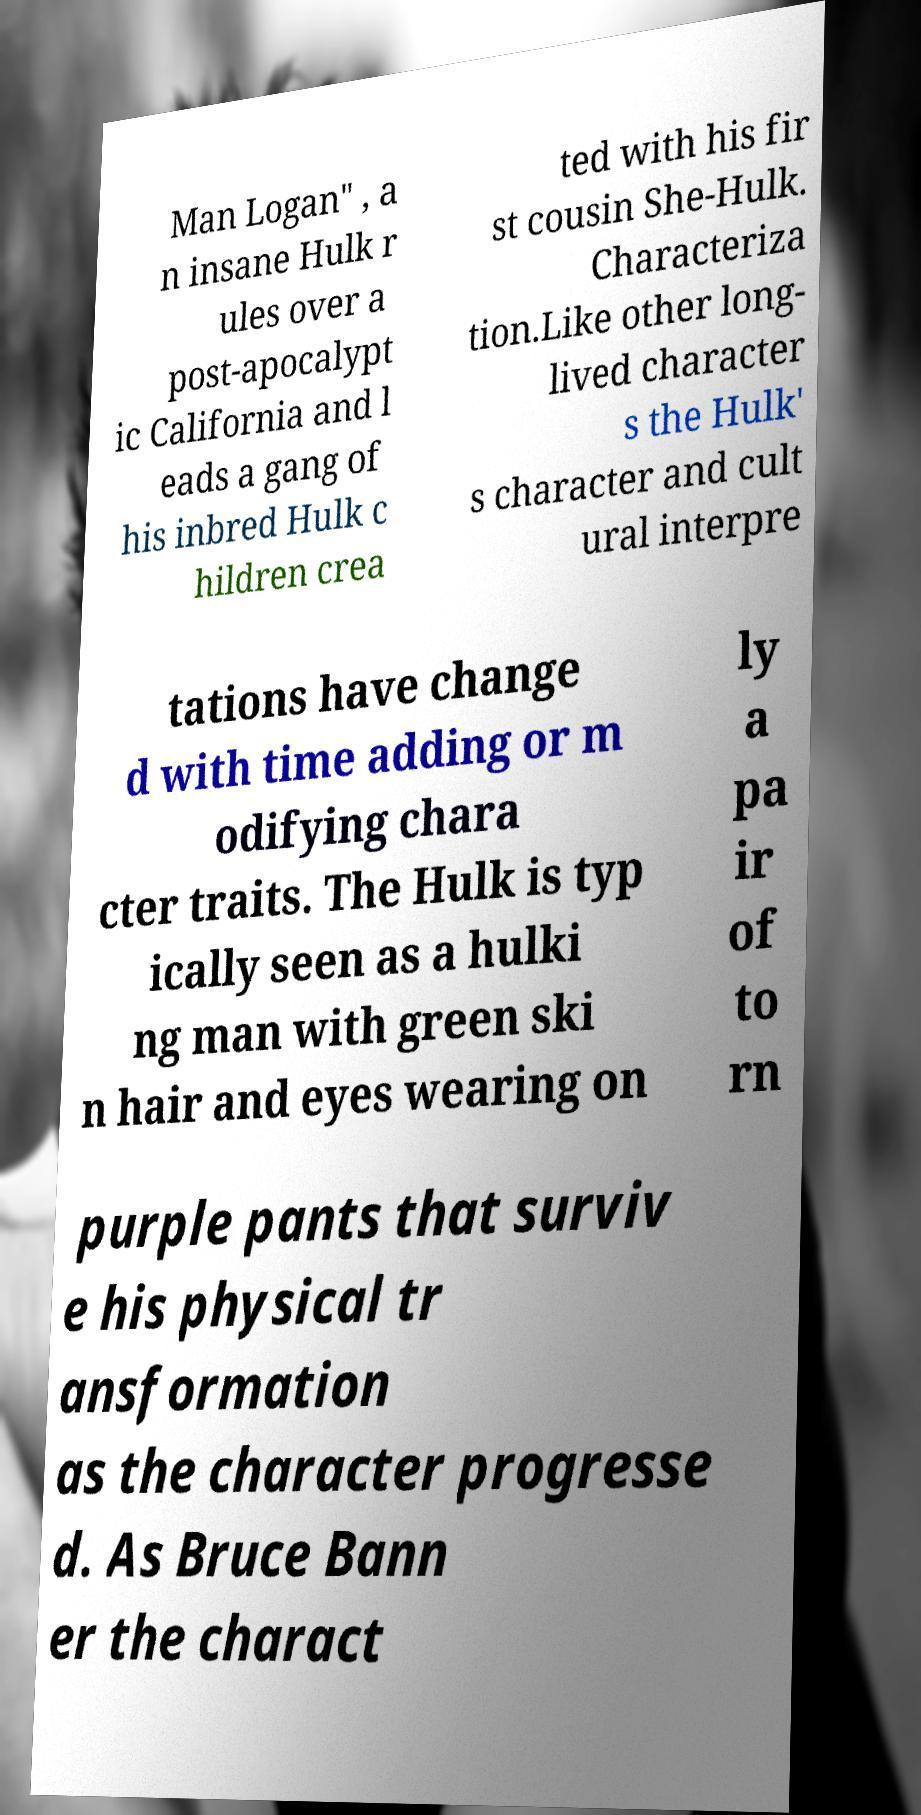Can you read and provide the text displayed in the image?This photo seems to have some interesting text. Can you extract and type it out for me? Man Logan" , a n insane Hulk r ules over a post-apocalypt ic California and l eads a gang of his inbred Hulk c hildren crea ted with his fir st cousin She-Hulk. Characteriza tion.Like other long- lived character s the Hulk' s character and cult ural interpre tations have change d with time adding or m odifying chara cter traits. The Hulk is typ ically seen as a hulki ng man with green ski n hair and eyes wearing on ly a pa ir of to rn purple pants that surviv e his physical tr ansformation as the character progresse d. As Bruce Bann er the charact 